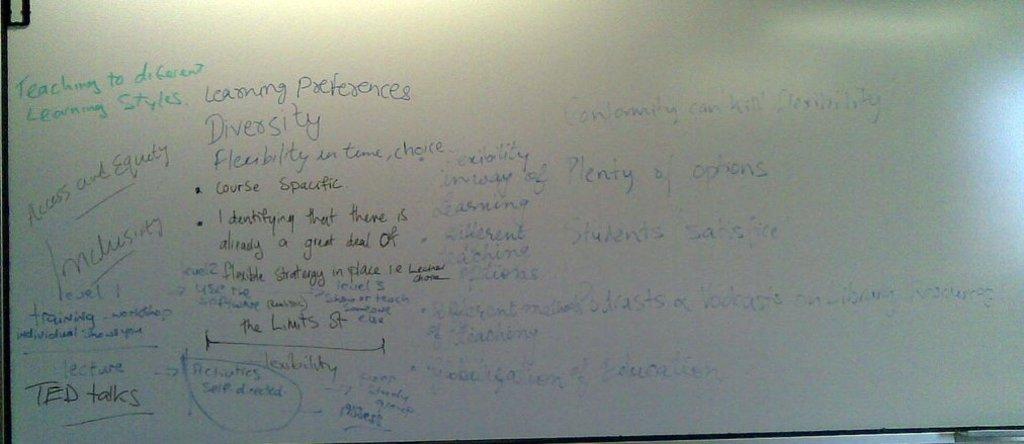What is the topic of the notes?
Provide a short and direct response. Teaching to different learning styles. What does it say in green writing?
Give a very brief answer. Teaching to different learning styles. 